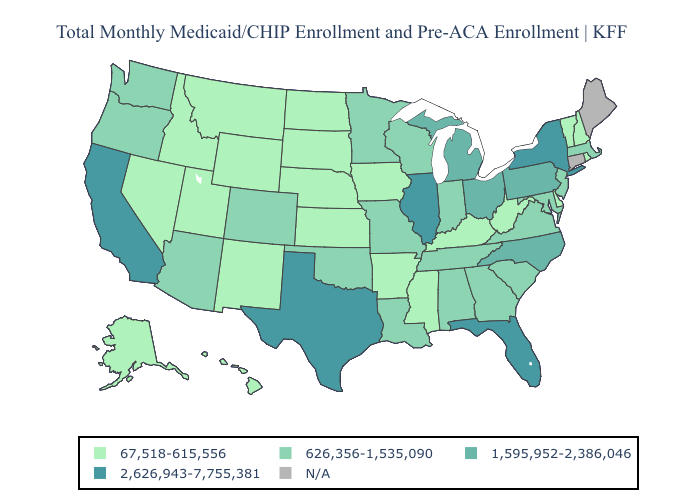Is the legend a continuous bar?
Answer briefly. No. Which states have the lowest value in the USA?
Concise answer only. Alaska, Arkansas, Delaware, Hawaii, Idaho, Iowa, Kansas, Kentucky, Mississippi, Montana, Nebraska, Nevada, New Hampshire, New Mexico, North Dakota, Rhode Island, South Dakota, Utah, Vermont, West Virginia, Wyoming. Name the states that have a value in the range 2,626,943-7,755,381?
Quick response, please. California, Florida, Illinois, New York, Texas. Does the first symbol in the legend represent the smallest category?
Short answer required. Yes. Among the states that border Ohio , does West Virginia have the lowest value?
Be succinct. Yes. Name the states that have a value in the range 2,626,943-7,755,381?
Short answer required. California, Florida, Illinois, New York, Texas. What is the value of Maryland?
Quick response, please. 626,356-1,535,090. What is the lowest value in the West?
Write a very short answer. 67,518-615,556. What is the lowest value in the USA?
Write a very short answer. 67,518-615,556. Does the first symbol in the legend represent the smallest category?
Concise answer only. Yes. What is the value of Hawaii?
Give a very brief answer. 67,518-615,556. What is the lowest value in the South?
Keep it brief. 67,518-615,556. What is the value of Washington?
Answer briefly. 626,356-1,535,090. Name the states that have a value in the range 67,518-615,556?
Be succinct. Alaska, Arkansas, Delaware, Hawaii, Idaho, Iowa, Kansas, Kentucky, Mississippi, Montana, Nebraska, Nevada, New Hampshire, New Mexico, North Dakota, Rhode Island, South Dakota, Utah, Vermont, West Virginia, Wyoming. What is the value of Nebraska?
Quick response, please. 67,518-615,556. 